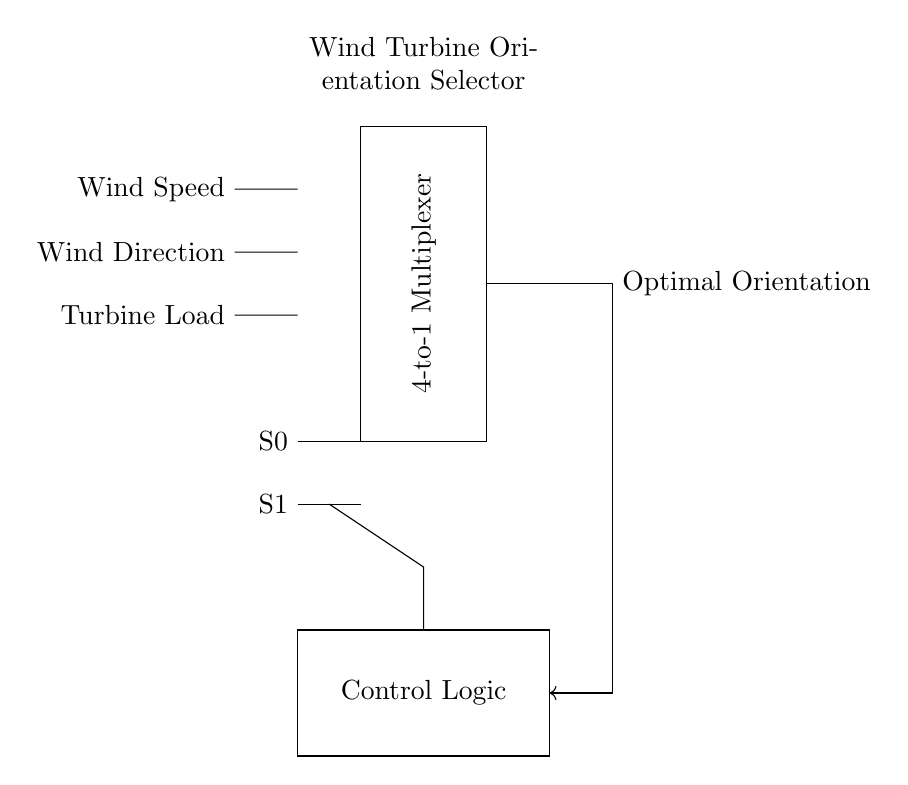What are the input signals for the multiplexer? The input signals are Wind Speed, Wind Direction, and Turbine Load, which are connected to the multiplexer and used for selecting the optimal turbine orientation.
Answer: Wind Speed, Wind Direction, Turbine Load What type of circuit is presented? The circuit is a multiplexer-based circuit designed for selecting the optimal orientation of a wind turbine based on input signals.
Answer: Multiplexer How many select lines does the multiplexer use? The multiplexer uses two select lines labeled S0 and S1, which determine the selection of the input signals.
Answer: Two What is the function of the control logic? The control logic processes the signals from the inputs and generates the necessary control actions that influence the multiplexer, ultimately determining the optimal orientation based on current wind conditions.
Answer: Control actions What does the feedback loop indicate? The feedback loop shows that the output of the multiplexer can influence the control logic, which allows for adjustments based on the selected optimal orientation, illustrating the system's adaptability.
Answer: Adaptability 